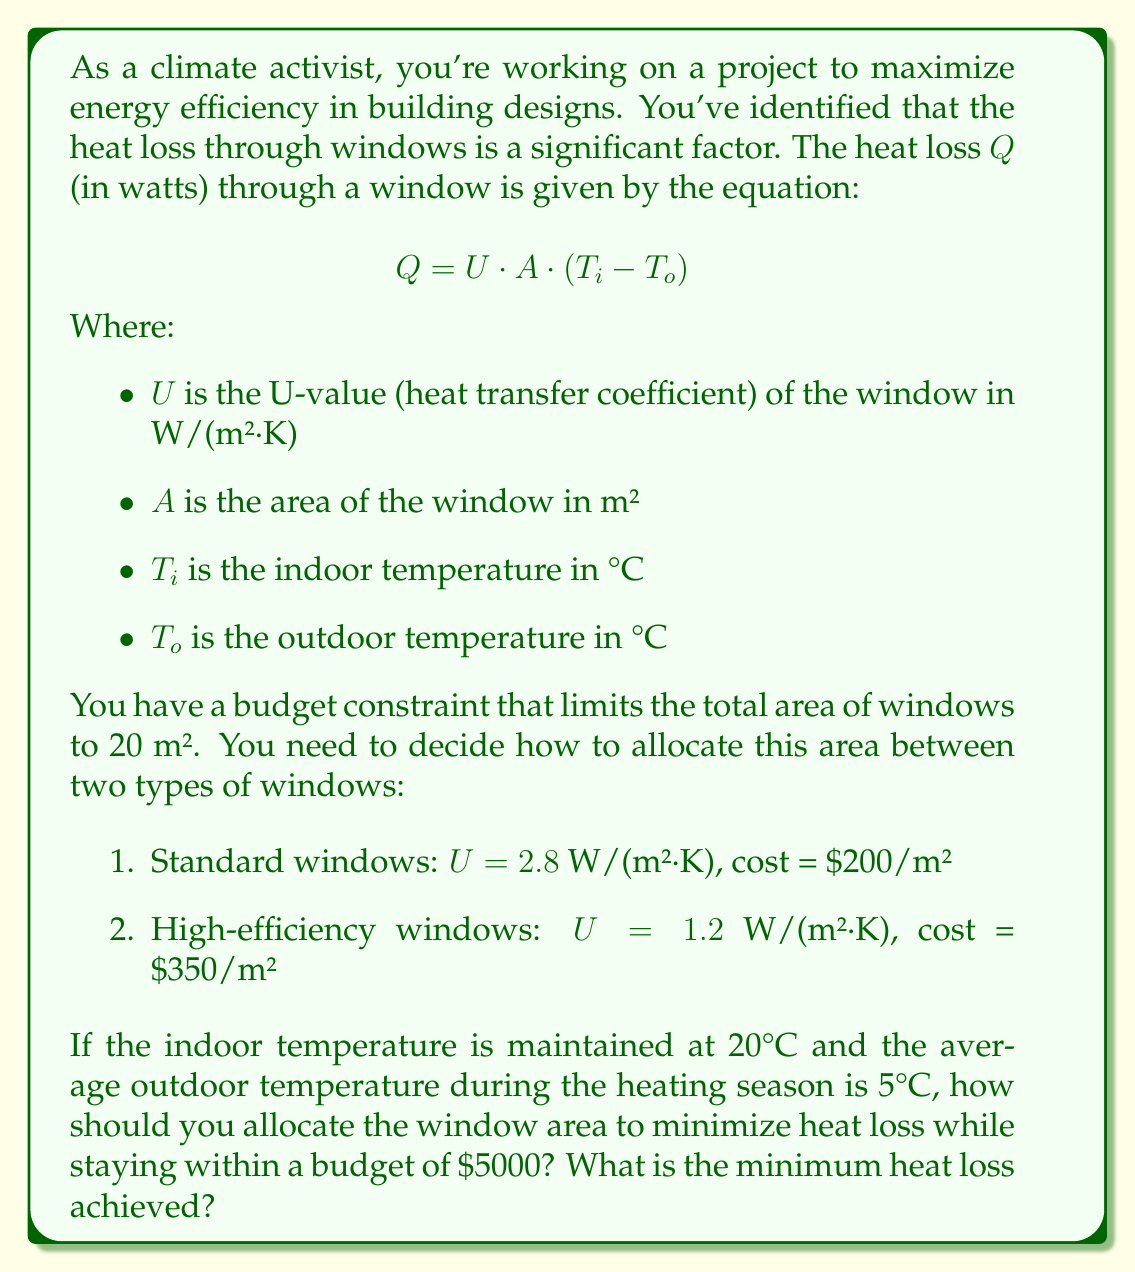Solve this math problem. To solve this optimization problem, we need to use linear programming. Let's define our variables:

$x$ = area of standard windows
$y$ = area of high-efficiency windows

Our objective is to minimize the heat loss:

$$Q = 2.8x(20-5) + 1.2y(20-5) = 42x + 18y$$

Subject to the constraints:

1. Total area: $x + y \leq 20$
2. Budget: $200x + 350y \leq 5000$
3. Non-negativity: $x \geq 0, y \geq 0$

To solve this, we can use the graphical method:

1. Plot the constraints:
   - $x + y = 20$
   - $200x + 350y = 5000$ (simplifies to $8x + 14y = 200$)

2. The feasible region is the area that satisfies all constraints.

3. The objective function lines are parallel to $42x + 18y = k$, where $k$ is a constant.

4. The optimal solution will be at one of the corner points of the feasible region.

5. The corner points are:
   (0, 14.29), (20, 0), and the intersection of the two constraint lines.

6. To find the intersection, solve:
   $x + y = 20$
   $8x + 14y = 200$
   
   Subtracting the first equation from the second:
   $7x + 13y = 180$
   $x + y = 20$
   
   Solving this system:
   $x = 10$, $y = 10$

7. Evaluate the objective function at each corner point:
   (0, 14.29): $Q = 257.22$
   (20, 0): $Q = 840$
   (10, 10): $Q = 600$

The minimum heat loss is achieved at the point (0, 14.29), which means using only high-efficiency windows.

However, this uses only $350 * 14.29 = 5001.50$ of the budget. We can reduce this slightly to exactly meet the budget constraint:

$350y = 5000$
$y = 14.2857$ m²

This is our optimal solution.
Answer: Allocate all 14.2857 m² to high-efficiency windows. The minimum heat loss achieved is 257.14 watts. 